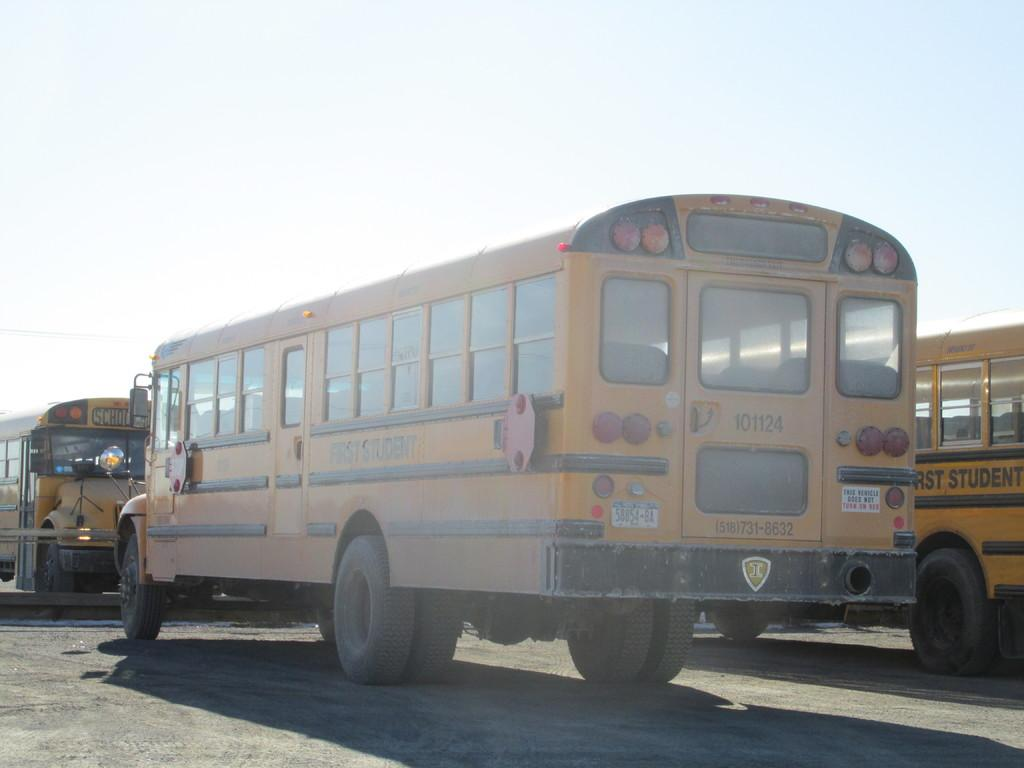How many school buses are in the image? There are three school buses in the image. What is the status of the school buses in the image? The school buses are parked. What color are the school buses in the image? The school buses are yellow in color. What can be seen in the background of the image? There is a sky visible in the background of the image. What taste does the sky have in the image? The sky does not have a taste, as it is not a consumable object. 